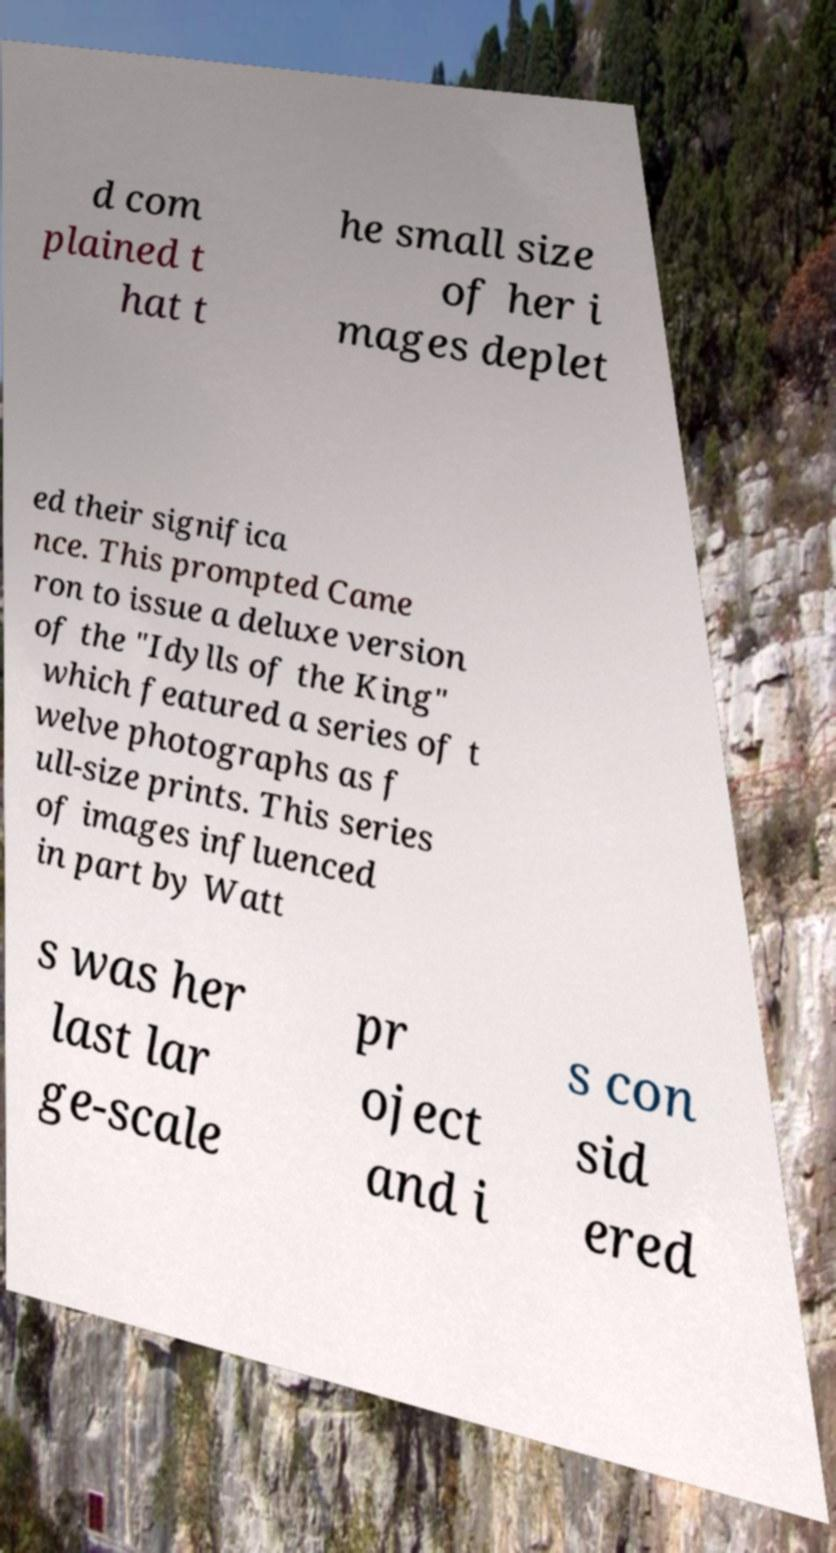Please read and relay the text visible in this image. What does it say? d com plained t hat t he small size of her i mages deplet ed their significa nce. This prompted Came ron to issue a deluxe version of the "Idylls of the King" which featured a series of t welve photographs as f ull-size prints. This series of images influenced in part by Watt s was her last lar ge-scale pr oject and i s con sid ered 